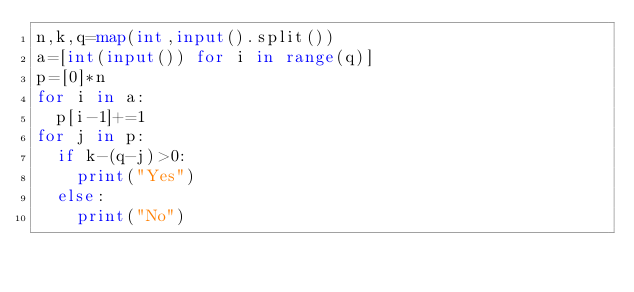<code> <loc_0><loc_0><loc_500><loc_500><_Python_>n,k,q=map(int,input().split())
a=[int(input()) for i in range(q)]
p=[0]*n
for i in a:
  p[i-1]+=1
for j in p:
  if k-(q-j)>0:
    print("Yes")
  else:
    print("No")
</code> 